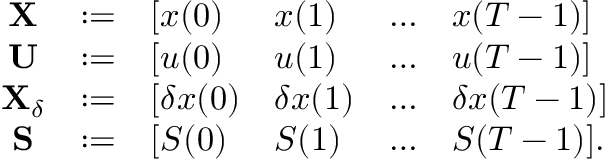Convert formula to latex. <formula><loc_0><loc_0><loc_500><loc_500>\begin{array} { r } { \begin{array} { c c l l l l } { X } & { \colon = } & { [ x ( 0 ) } & { x ( 1 ) } & { \dots } & { x ( T - 1 ) ] } \\ { U } & { \colon = } & { [ u ( 0 ) } & { u ( 1 ) } & { \dots } & { u ( T - 1 ) ] } \\ { X _ { \delta } } & { \colon = } & { [ \delta x ( 0 ) } & { \delta x ( 1 ) } & { \dots } & { \delta x ( T - 1 ) ] } \\ { S } & { \colon = } & { [ S ( 0 ) } & { S ( 1 ) } & { \dots } & { S ( T - 1 ) ] . } \end{array} } \end{array}</formula> 